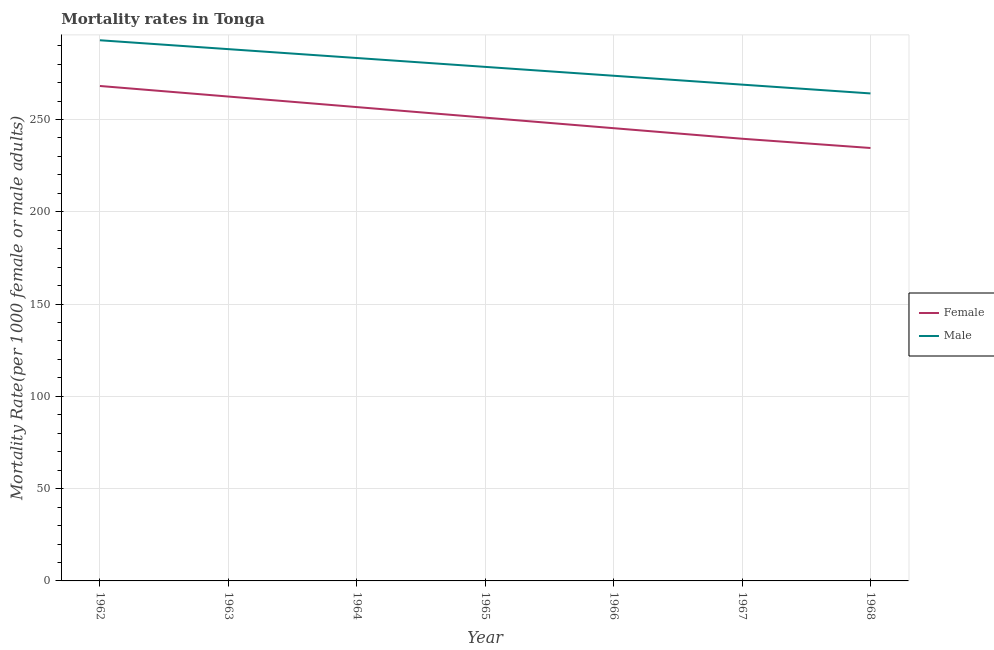How many different coloured lines are there?
Your response must be concise. 2. What is the male mortality rate in 1964?
Your answer should be very brief. 283.32. Across all years, what is the maximum male mortality rate?
Ensure brevity in your answer.  292.94. Across all years, what is the minimum female mortality rate?
Keep it short and to the point. 234.57. In which year was the male mortality rate maximum?
Provide a succinct answer. 1962. In which year was the male mortality rate minimum?
Offer a terse response. 1968. What is the total male mortality rate in the graph?
Your answer should be compact. 1949.64. What is the difference between the female mortality rate in 1962 and that in 1967?
Offer a very short reply. 28.58. What is the difference between the male mortality rate in 1964 and the female mortality rate in 1968?
Your response must be concise. 48.76. What is the average female mortality rate per year?
Your answer should be compact. 251.12. In the year 1965, what is the difference between the female mortality rate and male mortality rate?
Provide a short and direct response. -27.5. What is the ratio of the male mortality rate in 1962 to that in 1968?
Make the answer very short. 1.11. What is the difference between the highest and the second highest female mortality rate?
Offer a terse response. 5.72. What is the difference between the highest and the lowest male mortality rate?
Your answer should be compact. 28.81. Does the female mortality rate monotonically increase over the years?
Offer a terse response. No. Is the male mortality rate strictly greater than the female mortality rate over the years?
Your answer should be very brief. Yes. How many years are there in the graph?
Give a very brief answer. 7. Are the values on the major ticks of Y-axis written in scientific E-notation?
Your answer should be compact. No. Does the graph contain any zero values?
Your answer should be very brief. No. Does the graph contain grids?
Your response must be concise. Yes. Where does the legend appear in the graph?
Your answer should be very brief. Center right. What is the title of the graph?
Offer a terse response. Mortality rates in Tonga. Does "Male population" appear as one of the legend labels in the graph?
Ensure brevity in your answer.  No. What is the label or title of the Y-axis?
Provide a succinct answer. Mortality Rate(per 1000 female or male adults). What is the Mortality Rate(per 1000 female or male adults) of Female in 1962?
Your answer should be compact. 268.16. What is the Mortality Rate(per 1000 female or male adults) in Male in 1962?
Ensure brevity in your answer.  292.94. What is the Mortality Rate(per 1000 female or male adults) in Female in 1963?
Keep it short and to the point. 262.45. What is the Mortality Rate(per 1000 female or male adults) in Male in 1963?
Your answer should be very brief. 288.13. What is the Mortality Rate(per 1000 female or male adults) in Female in 1964?
Your response must be concise. 256.73. What is the Mortality Rate(per 1000 female or male adults) of Male in 1964?
Your answer should be very brief. 283.32. What is the Mortality Rate(per 1000 female or male adults) in Female in 1965?
Give a very brief answer. 251.01. What is the Mortality Rate(per 1000 female or male adults) in Male in 1965?
Keep it short and to the point. 278.51. What is the Mortality Rate(per 1000 female or male adults) in Female in 1966?
Offer a very short reply. 245.3. What is the Mortality Rate(per 1000 female or male adults) in Male in 1966?
Provide a succinct answer. 273.71. What is the Mortality Rate(per 1000 female or male adults) in Female in 1967?
Make the answer very short. 239.58. What is the Mortality Rate(per 1000 female or male adults) in Male in 1967?
Offer a terse response. 268.9. What is the Mortality Rate(per 1000 female or male adults) of Female in 1968?
Ensure brevity in your answer.  234.57. What is the Mortality Rate(per 1000 female or male adults) of Male in 1968?
Offer a very short reply. 264.13. Across all years, what is the maximum Mortality Rate(per 1000 female or male adults) in Female?
Offer a terse response. 268.16. Across all years, what is the maximum Mortality Rate(per 1000 female or male adults) in Male?
Ensure brevity in your answer.  292.94. Across all years, what is the minimum Mortality Rate(per 1000 female or male adults) in Female?
Provide a succinct answer. 234.57. Across all years, what is the minimum Mortality Rate(per 1000 female or male adults) of Male?
Offer a terse response. 264.13. What is the total Mortality Rate(per 1000 female or male adults) in Female in the graph?
Provide a short and direct response. 1757.81. What is the total Mortality Rate(per 1000 female or male adults) in Male in the graph?
Offer a very short reply. 1949.64. What is the difference between the Mortality Rate(per 1000 female or male adults) of Female in 1962 and that in 1963?
Keep it short and to the point. 5.72. What is the difference between the Mortality Rate(per 1000 female or male adults) of Male in 1962 and that in 1963?
Make the answer very short. 4.81. What is the difference between the Mortality Rate(per 1000 female or male adults) of Female in 1962 and that in 1964?
Offer a very short reply. 11.43. What is the difference between the Mortality Rate(per 1000 female or male adults) of Male in 1962 and that in 1964?
Provide a succinct answer. 9.62. What is the difference between the Mortality Rate(per 1000 female or male adults) of Female in 1962 and that in 1965?
Provide a short and direct response. 17.15. What is the difference between the Mortality Rate(per 1000 female or male adults) in Male in 1962 and that in 1965?
Your answer should be very brief. 14.42. What is the difference between the Mortality Rate(per 1000 female or male adults) of Female in 1962 and that in 1966?
Provide a short and direct response. 22.86. What is the difference between the Mortality Rate(per 1000 female or male adults) in Male in 1962 and that in 1966?
Make the answer very short. 19.23. What is the difference between the Mortality Rate(per 1000 female or male adults) in Female in 1962 and that in 1967?
Your answer should be very brief. 28.58. What is the difference between the Mortality Rate(per 1000 female or male adults) of Male in 1962 and that in 1967?
Provide a succinct answer. 24.04. What is the difference between the Mortality Rate(per 1000 female or male adults) of Female in 1962 and that in 1968?
Make the answer very short. 33.6. What is the difference between the Mortality Rate(per 1000 female or male adults) of Male in 1962 and that in 1968?
Your answer should be very brief. 28.81. What is the difference between the Mortality Rate(per 1000 female or male adults) of Female in 1963 and that in 1964?
Offer a very short reply. 5.72. What is the difference between the Mortality Rate(per 1000 female or male adults) of Male in 1963 and that in 1964?
Provide a succinct answer. 4.81. What is the difference between the Mortality Rate(per 1000 female or male adults) of Female in 1963 and that in 1965?
Your response must be concise. 11.43. What is the difference between the Mortality Rate(per 1000 female or male adults) of Male in 1963 and that in 1965?
Make the answer very short. 9.62. What is the difference between the Mortality Rate(per 1000 female or male adults) of Female in 1963 and that in 1966?
Make the answer very short. 17.15. What is the difference between the Mortality Rate(per 1000 female or male adults) of Male in 1963 and that in 1966?
Make the answer very short. 14.42. What is the difference between the Mortality Rate(per 1000 female or male adults) in Female in 1963 and that in 1967?
Give a very brief answer. 22.86. What is the difference between the Mortality Rate(per 1000 female or male adults) of Male in 1963 and that in 1967?
Offer a terse response. 19.23. What is the difference between the Mortality Rate(per 1000 female or male adults) of Female in 1963 and that in 1968?
Ensure brevity in your answer.  27.88. What is the difference between the Mortality Rate(per 1000 female or male adults) in Male in 1963 and that in 1968?
Keep it short and to the point. 24. What is the difference between the Mortality Rate(per 1000 female or male adults) of Female in 1964 and that in 1965?
Your response must be concise. 5.72. What is the difference between the Mortality Rate(per 1000 female or male adults) of Male in 1964 and that in 1965?
Provide a succinct answer. 4.81. What is the difference between the Mortality Rate(per 1000 female or male adults) of Female in 1964 and that in 1966?
Make the answer very short. 11.43. What is the difference between the Mortality Rate(per 1000 female or male adults) of Male in 1964 and that in 1966?
Your answer should be very brief. 9.62. What is the difference between the Mortality Rate(per 1000 female or male adults) of Female in 1964 and that in 1967?
Offer a terse response. 17.15. What is the difference between the Mortality Rate(per 1000 female or male adults) in Male in 1964 and that in 1967?
Provide a short and direct response. 14.42. What is the difference between the Mortality Rate(per 1000 female or male adults) of Female in 1964 and that in 1968?
Make the answer very short. 22.16. What is the difference between the Mortality Rate(per 1000 female or male adults) in Male in 1964 and that in 1968?
Offer a very short reply. 19.19. What is the difference between the Mortality Rate(per 1000 female or male adults) in Female in 1965 and that in 1966?
Provide a succinct answer. 5.72. What is the difference between the Mortality Rate(per 1000 female or male adults) in Male in 1965 and that in 1966?
Keep it short and to the point. 4.81. What is the difference between the Mortality Rate(per 1000 female or male adults) of Female in 1965 and that in 1967?
Ensure brevity in your answer.  11.43. What is the difference between the Mortality Rate(per 1000 female or male adults) in Male in 1965 and that in 1967?
Your response must be concise. 9.62. What is the difference between the Mortality Rate(per 1000 female or male adults) in Female in 1965 and that in 1968?
Keep it short and to the point. 16.45. What is the difference between the Mortality Rate(per 1000 female or male adults) in Male in 1965 and that in 1968?
Make the answer very short. 14.38. What is the difference between the Mortality Rate(per 1000 female or male adults) of Female in 1966 and that in 1967?
Provide a succinct answer. 5.72. What is the difference between the Mortality Rate(per 1000 female or male adults) of Male in 1966 and that in 1967?
Provide a short and direct response. 4.81. What is the difference between the Mortality Rate(per 1000 female or male adults) of Female in 1966 and that in 1968?
Keep it short and to the point. 10.73. What is the difference between the Mortality Rate(per 1000 female or male adults) of Male in 1966 and that in 1968?
Make the answer very short. 9.58. What is the difference between the Mortality Rate(per 1000 female or male adults) of Female in 1967 and that in 1968?
Keep it short and to the point. 5.02. What is the difference between the Mortality Rate(per 1000 female or male adults) of Male in 1967 and that in 1968?
Provide a succinct answer. 4.77. What is the difference between the Mortality Rate(per 1000 female or male adults) in Female in 1962 and the Mortality Rate(per 1000 female or male adults) in Male in 1963?
Offer a terse response. -19.97. What is the difference between the Mortality Rate(per 1000 female or male adults) in Female in 1962 and the Mortality Rate(per 1000 female or male adults) in Male in 1964?
Offer a terse response. -15.16. What is the difference between the Mortality Rate(per 1000 female or male adults) of Female in 1962 and the Mortality Rate(per 1000 female or male adults) of Male in 1965?
Offer a very short reply. -10.35. What is the difference between the Mortality Rate(per 1000 female or male adults) in Female in 1962 and the Mortality Rate(per 1000 female or male adults) in Male in 1966?
Offer a very short reply. -5.54. What is the difference between the Mortality Rate(per 1000 female or male adults) in Female in 1962 and the Mortality Rate(per 1000 female or male adults) in Male in 1967?
Your answer should be compact. -0.74. What is the difference between the Mortality Rate(per 1000 female or male adults) of Female in 1962 and the Mortality Rate(per 1000 female or male adults) of Male in 1968?
Your answer should be very brief. 4.03. What is the difference between the Mortality Rate(per 1000 female or male adults) in Female in 1963 and the Mortality Rate(per 1000 female or male adults) in Male in 1964?
Your response must be concise. -20.88. What is the difference between the Mortality Rate(per 1000 female or male adults) of Female in 1963 and the Mortality Rate(per 1000 female or male adults) of Male in 1965?
Provide a succinct answer. -16.07. What is the difference between the Mortality Rate(per 1000 female or male adults) of Female in 1963 and the Mortality Rate(per 1000 female or male adults) of Male in 1966?
Your answer should be very brief. -11.26. What is the difference between the Mortality Rate(per 1000 female or male adults) of Female in 1963 and the Mortality Rate(per 1000 female or male adults) of Male in 1967?
Your response must be concise. -6.45. What is the difference between the Mortality Rate(per 1000 female or male adults) in Female in 1963 and the Mortality Rate(per 1000 female or male adults) in Male in 1968?
Give a very brief answer. -1.68. What is the difference between the Mortality Rate(per 1000 female or male adults) of Female in 1964 and the Mortality Rate(per 1000 female or male adults) of Male in 1965?
Ensure brevity in your answer.  -21.78. What is the difference between the Mortality Rate(per 1000 female or male adults) in Female in 1964 and the Mortality Rate(per 1000 female or male adults) in Male in 1966?
Offer a terse response. -16.98. What is the difference between the Mortality Rate(per 1000 female or male adults) of Female in 1964 and the Mortality Rate(per 1000 female or male adults) of Male in 1967?
Keep it short and to the point. -12.17. What is the difference between the Mortality Rate(per 1000 female or male adults) in Female in 1964 and the Mortality Rate(per 1000 female or male adults) in Male in 1968?
Keep it short and to the point. -7.4. What is the difference between the Mortality Rate(per 1000 female or male adults) in Female in 1965 and the Mortality Rate(per 1000 female or male adults) in Male in 1966?
Your answer should be compact. -22.69. What is the difference between the Mortality Rate(per 1000 female or male adults) in Female in 1965 and the Mortality Rate(per 1000 female or male adults) in Male in 1967?
Your response must be concise. -17.89. What is the difference between the Mortality Rate(per 1000 female or male adults) of Female in 1965 and the Mortality Rate(per 1000 female or male adults) of Male in 1968?
Give a very brief answer. -13.12. What is the difference between the Mortality Rate(per 1000 female or male adults) of Female in 1966 and the Mortality Rate(per 1000 female or male adults) of Male in 1967?
Provide a succinct answer. -23.6. What is the difference between the Mortality Rate(per 1000 female or male adults) of Female in 1966 and the Mortality Rate(per 1000 female or male adults) of Male in 1968?
Ensure brevity in your answer.  -18.83. What is the difference between the Mortality Rate(per 1000 female or male adults) in Female in 1967 and the Mortality Rate(per 1000 female or male adults) in Male in 1968?
Your response must be concise. -24.55. What is the average Mortality Rate(per 1000 female or male adults) in Female per year?
Your answer should be compact. 251.12. What is the average Mortality Rate(per 1000 female or male adults) of Male per year?
Offer a terse response. 278.52. In the year 1962, what is the difference between the Mortality Rate(per 1000 female or male adults) of Female and Mortality Rate(per 1000 female or male adults) of Male?
Provide a succinct answer. -24.77. In the year 1963, what is the difference between the Mortality Rate(per 1000 female or male adults) of Female and Mortality Rate(per 1000 female or male adults) of Male?
Provide a succinct answer. -25.68. In the year 1964, what is the difference between the Mortality Rate(per 1000 female or male adults) of Female and Mortality Rate(per 1000 female or male adults) of Male?
Your response must be concise. -26.59. In the year 1965, what is the difference between the Mortality Rate(per 1000 female or male adults) in Female and Mortality Rate(per 1000 female or male adults) in Male?
Offer a very short reply. -27.5. In the year 1966, what is the difference between the Mortality Rate(per 1000 female or male adults) of Female and Mortality Rate(per 1000 female or male adults) of Male?
Provide a short and direct response. -28.41. In the year 1967, what is the difference between the Mortality Rate(per 1000 female or male adults) of Female and Mortality Rate(per 1000 female or male adults) of Male?
Provide a short and direct response. -29.32. In the year 1968, what is the difference between the Mortality Rate(per 1000 female or male adults) of Female and Mortality Rate(per 1000 female or male adults) of Male?
Provide a short and direct response. -29.56. What is the ratio of the Mortality Rate(per 1000 female or male adults) in Female in 1962 to that in 1963?
Your answer should be compact. 1.02. What is the ratio of the Mortality Rate(per 1000 female or male adults) in Male in 1962 to that in 1963?
Provide a short and direct response. 1.02. What is the ratio of the Mortality Rate(per 1000 female or male adults) of Female in 1962 to that in 1964?
Offer a terse response. 1.04. What is the ratio of the Mortality Rate(per 1000 female or male adults) in Male in 1962 to that in 1964?
Give a very brief answer. 1.03. What is the ratio of the Mortality Rate(per 1000 female or male adults) of Female in 1962 to that in 1965?
Offer a terse response. 1.07. What is the ratio of the Mortality Rate(per 1000 female or male adults) in Male in 1962 to that in 1965?
Provide a short and direct response. 1.05. What is the ratio of the Mortality Rate(per 1000 female or male adults) in Female in 1962 to that in 1966?
Provide a succinct answer. 1.09. What is the ratio of the Mortality Rate(per 1000 female or male adults) of Male in 1962 to that in 1966?
Offer a very short reply. 1.07. What is the ratio of the Mortality Rate(per 1000 female or male adults) in Female in 1962 to that in 1967?
Give a very brief answer. 1.12. What is the ratio of the Mortality Rate(per 1000 female or male adults) in Male in 1962 to that in 1967?
Make the answer very short. 1.09. What is the ratio of the Mortality Rate(per 1000 female or male adults) of Female in 1962 to that in 1968?
Your answer should be compact. 1.14. What is the ratio of the Mortality Rate(per 1000 female or male adults) of Male in 1962 to that in 1968?
Ensure brevity in your answer.  1.11. What is the ratio of the Mortality Rate(per 1000 female or male adults) in Female in 1963 to that in 1964?
Keep it short and to the point. 1.02. What is the ratio of the Mortality Rate(per 1000 female or male adults) of Female in 1963 to that in 1965?
Provide a short and direct response. 1.05. What is the ratio of the Mortality Rate(per 1000 female or male adults) of Male in 1963 to that in 1965?
Keep it short and to the point. 1.03. What is the ratio of the Mortality Rate(per 1000 female or male adults) of Female in 1963 to that in 1966?
Your answer should be very brief. 1.07. What is the ratio of the Mortality Rate(per 1000 female or male adults) in Male in 1963 to that in 1966?
Offer a very short reply. 1.05. What is the ratio of the Mortality Rate(per 1000 female or male adults) of Female in 1963 to that in 1967?
Offer a terse response. 1.1. What is the ratio of the Mortality Rate(per 1000 female or male adults) of Male in 1963 to that in 1967?
Keep it short and to the point. 1.07. What is the ratio of the Mortality Rate(per 1000 female or male adults) of Female in 1963 to that in 1968?
Provide a succinct answer. 1.12. What is the ratio of the Mortality Rate(per 1000 female or male adults) of Male in 1963 to that in 1968?
Ensure brevity in your answer.  1.09. What is the ratio of the Mortality Rate(per 1000 female or male adults) of Female in 1964 to that in 1965?
Provide a short and direct response. 1.02. What is the ratio of the Mortality Rate(per 1000 female or male adults) of Male in 1964 to that in 1965?
Your answer should be very brief. 1.02. What is the ratio of the Mortality Rate(per 1000 female or male adults) of Female in 1964 to that in 1966?
Provide a succinct answer. 1.05. What is the ratio of the Mortality Rate(per 1000 female or male adults) in Male in 1964 to that in 1966?
Offer a very short reply. 1.04. What is the ratio of the Mortality Rate(per 1000 female or male adults) in Female in 1964 to that in 1967?
Keep it short and to the point. 1.07. What is the ratio of the Mortality Rate(per 1000 female or male adults) of Male in 1964 to that in 1967?
Keep it short and to the point. 1.05. What is the ratio of the Mortality Rate(per 1000 female or male adults) in Female in 1964 to that in 1968?
Offer a terse response. 1.09. What is the ratio of the Mortality Rate(per 1000 female or male adults) of Male in 1964 to that in 1968?
Provide a short and direct response. 1.07. What is the ratio of the Mortality Rate(per 1000 female or male adults) of Female in 1965 to that in 1966?
Your answer should be very brief. 1.02. What is the ratio of the Mortality Rate(per 1000 female or male adults) in Male in 1965 to that in 1966?
Your answer should be very brief. 1.02. What is the ratio of the Mortality Rate(per 1000 female or male adults) of Female in 1965 to that in 1967?
Provide a short and direct response. 1.05. What is the ratio of the Mortality Rate(per 1000 female or male adults) of Male in 1965 to that in 1967?
Your answer should be very brief. 1.04. What is the ratio of the Mortality Rate(per 1000 female or male adults) of Female in 1965 to that in 1968?
Your response must be concise. 1.07. What is the ratio of the Mortality Rate(per 1000 female or male adults) in Male in 1965 to that in 1968?
Offer a very short reply. 1.05. What is the ratio of the Mortality Rate(per 1000 female or male adults) of Female in 1966 to that in 1967?
Give a very brief answer. 1.02. What is the ratio of the Mortality Rate(per 1000 female or male adults) in Male in 1966 to that in 1967?
Your answer should be compact. 1.02. What is the ratio of the Mortality Rate(per 1000 female or male adults) in Female in 1966 to that in 1968?
Make the answer very short. 1.05. What is the ratio of the Mortality Rate(per 1000 female or male adults) of Male in 1966 to that in 1968?
Offer a terse response. 1.04. What is the ratio of the Mortality Rate(per 1000 female or male adults) of Female in 1967 to that in 1968?
Provide a short and direct response. 1.02. What is the ratio of the Mortality Rate(per 1000 female or male adults) in Male in 1967 to that in 1968?
Provide a short and direct response. 1.02. What is the difference between the highest and the second highest Mortality Rate(per 1000 female or male adults) of Female?
Provide a short and direct response. 5.72. What is the difference between the highest and the second highest Mortality Rate(per 1000 female or male adults) of Male?
Offer a very short reply. 4.81. What is the difference between the highest and the lowest Mortality Rate(per 1000 female or male adults) of Female?
Provide a succinct answer. 33.6. What is the difference between the highest and the lowest Mortality Rate(per 1000 female or male adults) in Male?
Ensure brevity in your answer.  28.81. 